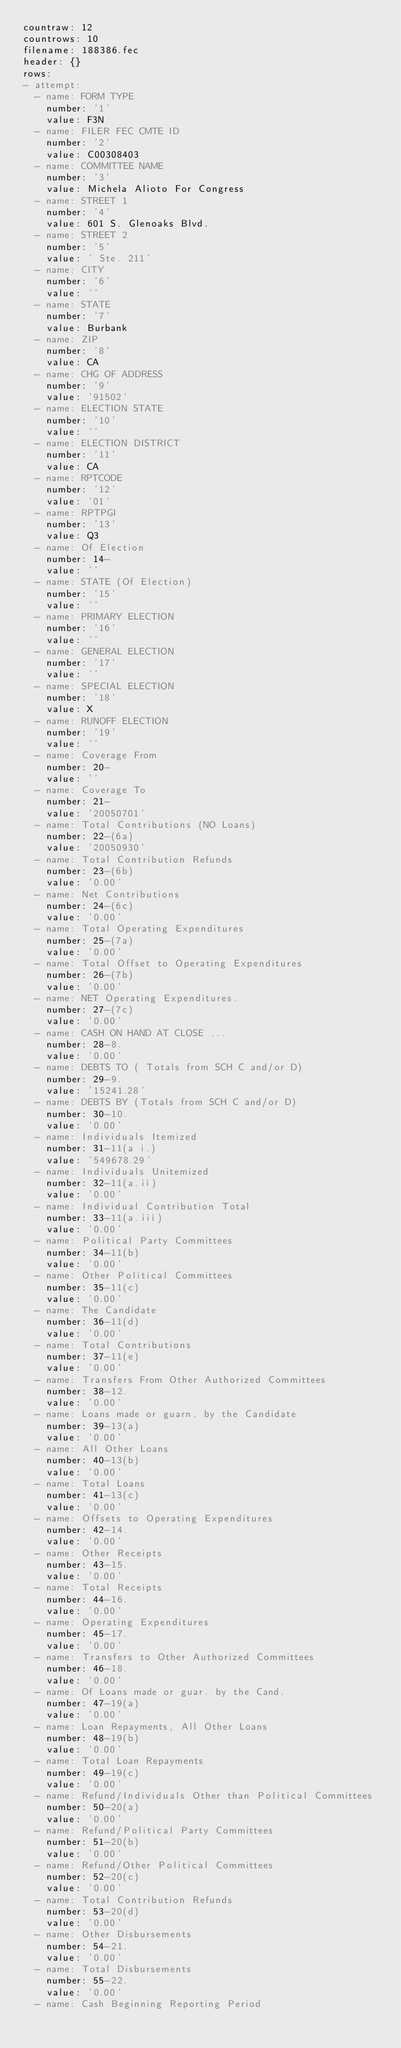<code> <loc_0><loc_0><loc_500><loc_500><_YAML_>countraw: 12
countrows: 10
filename: 188386.fec
header: {}
rows:
- attempt:
  - name: FORM TYPE
    number: '1'
    value: F3N
  - name: FILER FEC CMTE ID
    number: '2'
    value: C00308403
  - name: COMMITTEE NAME
    number: '3'
    value: Michela Alioto For Congress
  - name: STREET 1
    number: '4'
    value: 601 S. Glenoaks Blvd.
  - name: STREET 2
    number: '5'
    value: ' Ste. 211'
  - name: CITY
    number: '6'
    value: ''
  - name: STATE
    number: '7'
    value: Burbank
  - name: ZIP
    number: '8'
    value: CA
  - name: CHG OF ADDRESS
    number: '9'
    value: '91502'
  - name: ELECTION STATE
    number: '10'
    value: ''
  - name: ELECTION DISTRICT
    number: '11'
    value: CA
  - name: RPTCODE
    number: '12'
    value: '01'
  - name: RPTPGI
    number: '13'
    value: Q3
  - name: Of Election
    number: 14-
    value: ''
  - name: STATE (Of Election)
    number: '15'
    value: ''
  - name: PRIMARY ELECTION
    number: '16'
    value: ''
  - name: GENERAL ELECTION
    number: '17'
    value: ''
  - name: SPECIAL ELECTION
    number: '18'
    value: X
  - name: RUNOFF ELECTION
    number: '19'
    value: ''
  - name: Coverage From
    number: 20-
    value: ''
  - name: Coverage To
    number: 21-
    value: '20050701'
  - name: Total Contributions (NO Loans)
    number: 22-(6a)
    value: '20050930'
  - name: Total Contribution Refunds
    number: 23-(6b)
    value: '0.00'
  - name: Net Contributions
    number: 24-(6c)
    value: '0.00'
  - name: Total Operating Expenditures
    number: 25-(7a)
    value: '0.00'
  - name: Total Offset to Operating Expenditures
    number: 26-(7b)
    value: '0.00'
  - name: NET Operating Expenditures.
    number: 27-(7c)
    value: '0.00'
  - name: CASH ON HAND AT CLOSE ...
    number: 28-8.
    value: '0.00'
  - name: DEBTS TO ( Totals from SCH C and/or D)
    number: 29-9.
    value: '15241.28'
  - name: DEBTS BY (Totals from SCH C and/or D)
    number: 30-10.
    value: '0.00'
  - name: Individuals Itemized
    number: 31-11(a i.)
    value: '549678.29'
  - name: Individuals Unitemized
    number: 32-11(a.ii)
    value: '0.00'
  - name: Individual Contribution Total
    number: 33-11(a.iii)
    value: '0.00'
  - name: Political Party Committees
    number: 34-11(b)
    value: '0.00'
  - name: Other Political Committees
    number: 35-11(c)
    value: '0.00'
  - name: The Candidate
    number: 36-11(d)
    value: '0.00'
  - name: Total Contributions
    number: 37-11(e)
    value: '0.00'
  - name: Transfers From Other Authorized Committees
    number: 38-12.
    value: '0.00'
  - name: Loans made or guarn. by the Candidate
    number: 39-13(a)
    value: '0.00'
  - name: All Other Loans
    number: 40-13(b)
    value: '0.00'
  - name: Total Loans
    number: 41-13(c)
    value: '0.00'
  - name: Offsets to Operating Expenditures
    number: 42-14.
    value: '0.00'
  - name: Other Receipts
    number: 43-15.
    value: '0.00'
  - name: Total Receipts
    number: 44-16.
    value: '0.00'
  - name: Operating Expenditures
    number: 45-17.
    value: '0.00'
  - name: Transfers to Other Authorized Committees
    number: 46-18.
    value: '0.00'
  - name: Of Loans made or guar. by the Cand.
    number: 47-19(a)
    value: '0.00'
  - name: Loan Repayments, All Other Loans
    number: 48-19(b)
    value: '0.00'
  - name: Total Loan Repayments
    number: 49-19(c)
    value: '0.00'
  - name: Refund/Individuals Other than Political Committees
    number: 50-20(a)
    value: '0.00'
  - name: Refund/Political Party Committees
    number: 51-20(b)
    value: '0.00'
  - name: Refund/Other Political Committees
    number: 52-20(c)
    value: '0.00'
  - name: Total Contribution Refunds
    number: 53-20(d)
    value: '0.00'
  - name: Other Disbursements
    number: 54-21.
    value: '0.00'
  - name: Total Disbursements
    number: 55-22.
    value: '0.00'
  - name: Cash Beginning Reporting Period</code> 